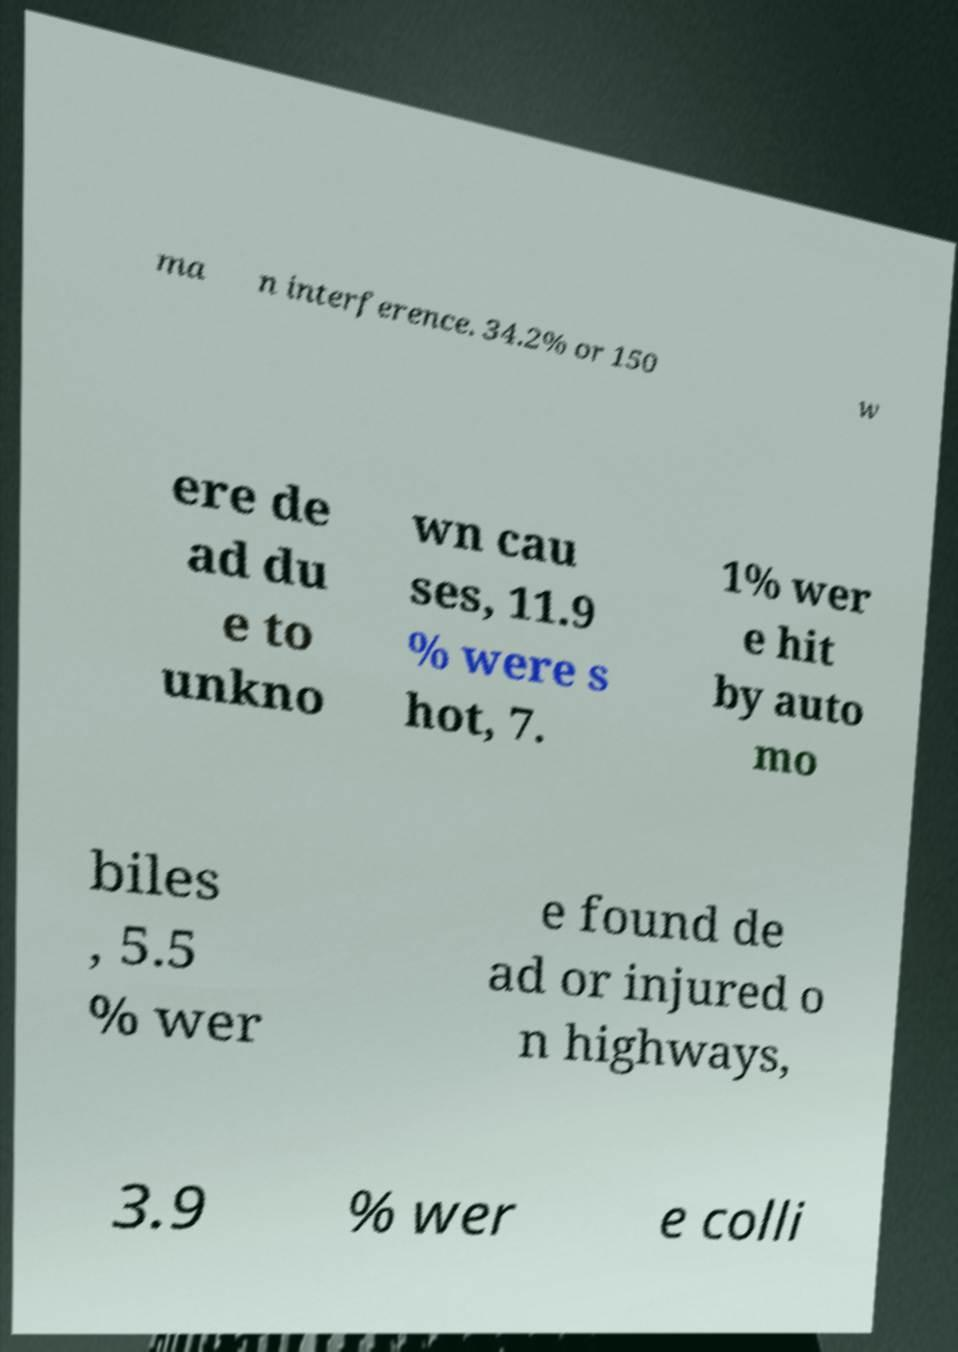What messages or text are displayed in this image? I need them in a readable, typed format. ma n interference. 34.2% or 150 w ere de ad du e to unkno wn cau ses, 11.9 % were s hot, 7. 1% wer e hit by auto mo biles , 5.5 % wer e found de ad or injured o n highways, 3.9 % wer e colli 